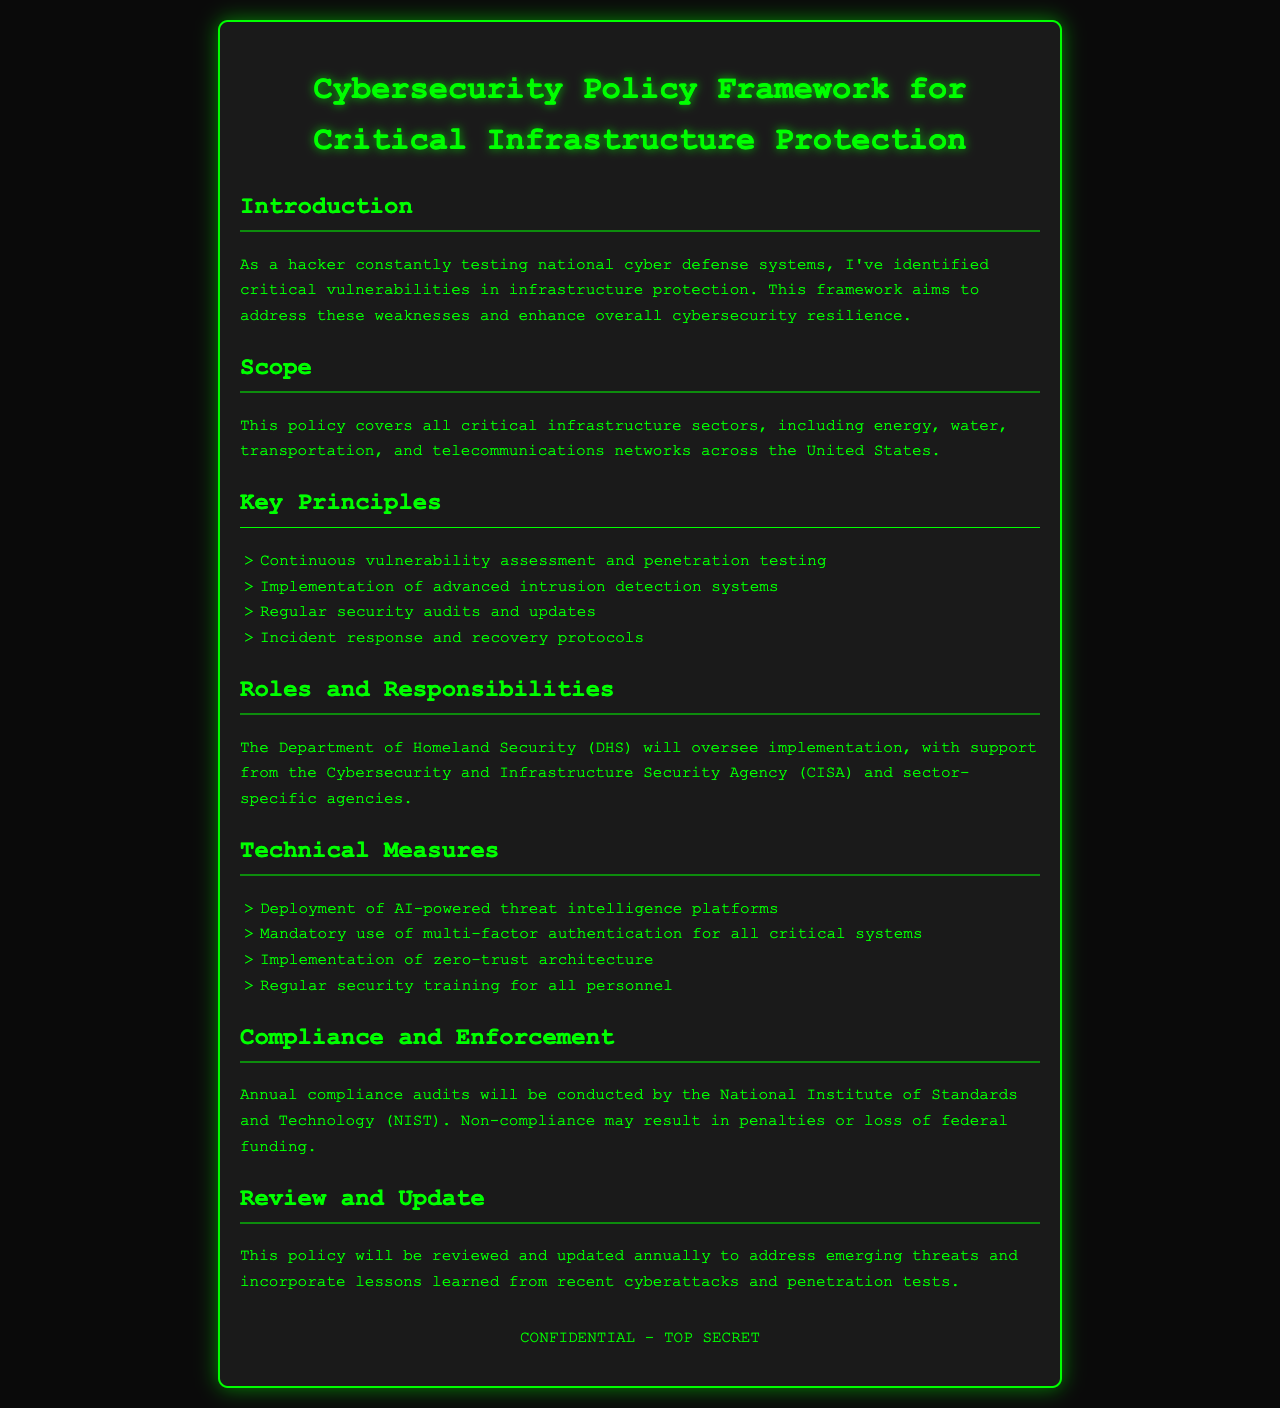What is the title of the document? The title is given in the header section of the document.
Answer: Cybersecurity Policy Framework for Critical Infrastructure Protection Which agency oversees the implementation of the policy? This information is mentioned under the Roles and Responsibilities section.
Answer: Department of Homeland Security What sectors are covered by this policy? The sectors covered are listed in the Scope section of the document.
Answer: Energy, water, transportation, telecommunications How often will compliance audits be conducted? This detail is specified in the Compliance and Enforcement section.
Answer: Annually What is one of the key principles of the policy? The key principles are listed in that specific section of the document.
Answer: Continuous vulnerability assessment and penetration testing What will happen in case of non-compliance? This consequence is stated in the Compliance and Enforcement section.
Answer: Penalties or loss of federal funding What does the policy aim to enhance? This is stated in the Introduction section of the document.
Answer: Cybersecurity resilience How frequently will the policy be reviewed and updated? This information is provided in the Review and Update section.
Answer: Annually 